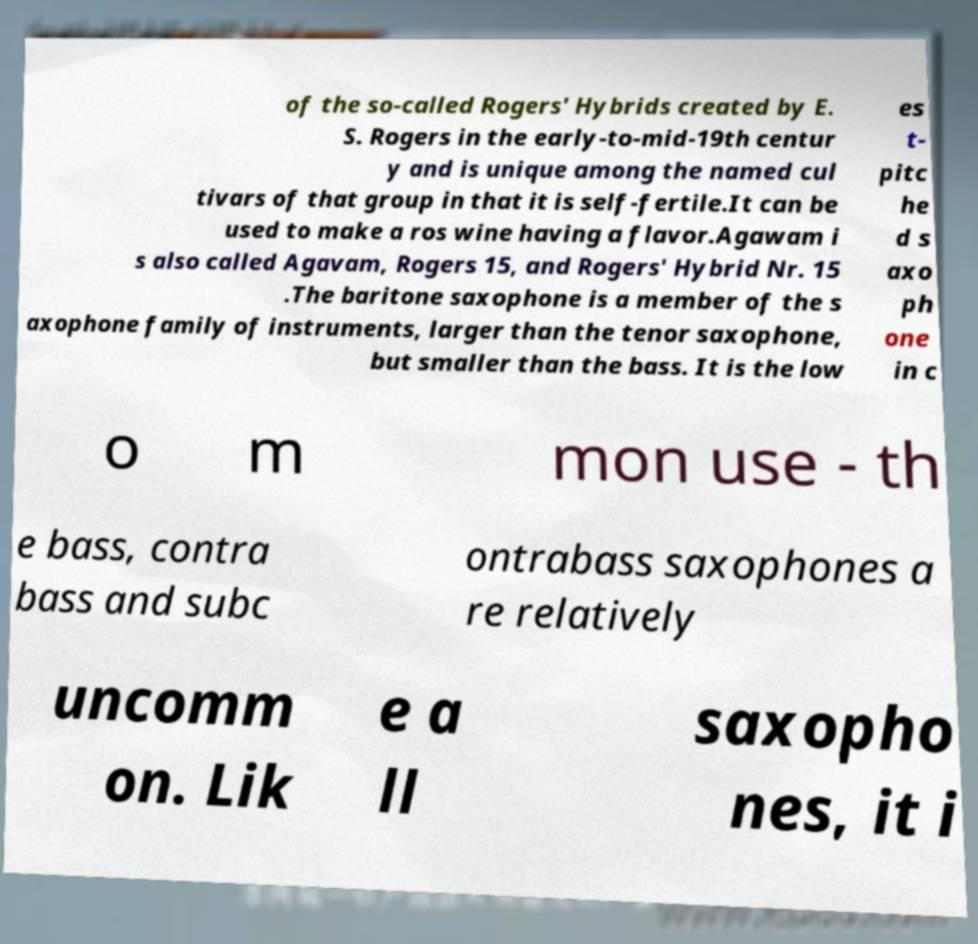For documentation purposes, I need the text within this image transcribed. Could you provide that? of the so-called Rogers' Hybrids created by E. S. Rogers in the early-to-mid-19th centur y and is unique among the named cul tivars of that group in that it is self-fertile.It can be used to make a ros wine having a flavor.Agawam i s also called Agavam, Rogers 15, and Rogers' Hybrid Nr. 15 .The baritone saxophone is a member of the s axophone family of instruments, larger than the tenor saxophone, but smaller than the bass. It is the low es t- pitc he d s axo ph one in c o m mon use - th e bass, contra bass and subc ontrabass saxophones a re relatively uncomm on. Lik e a ll saxopho nes, it i 